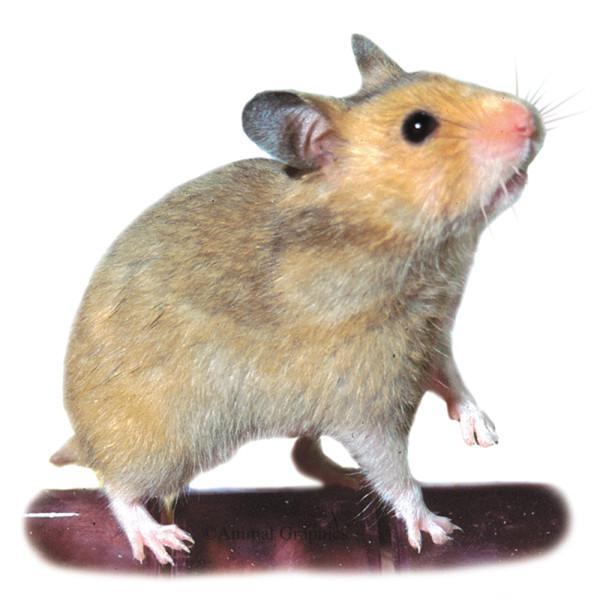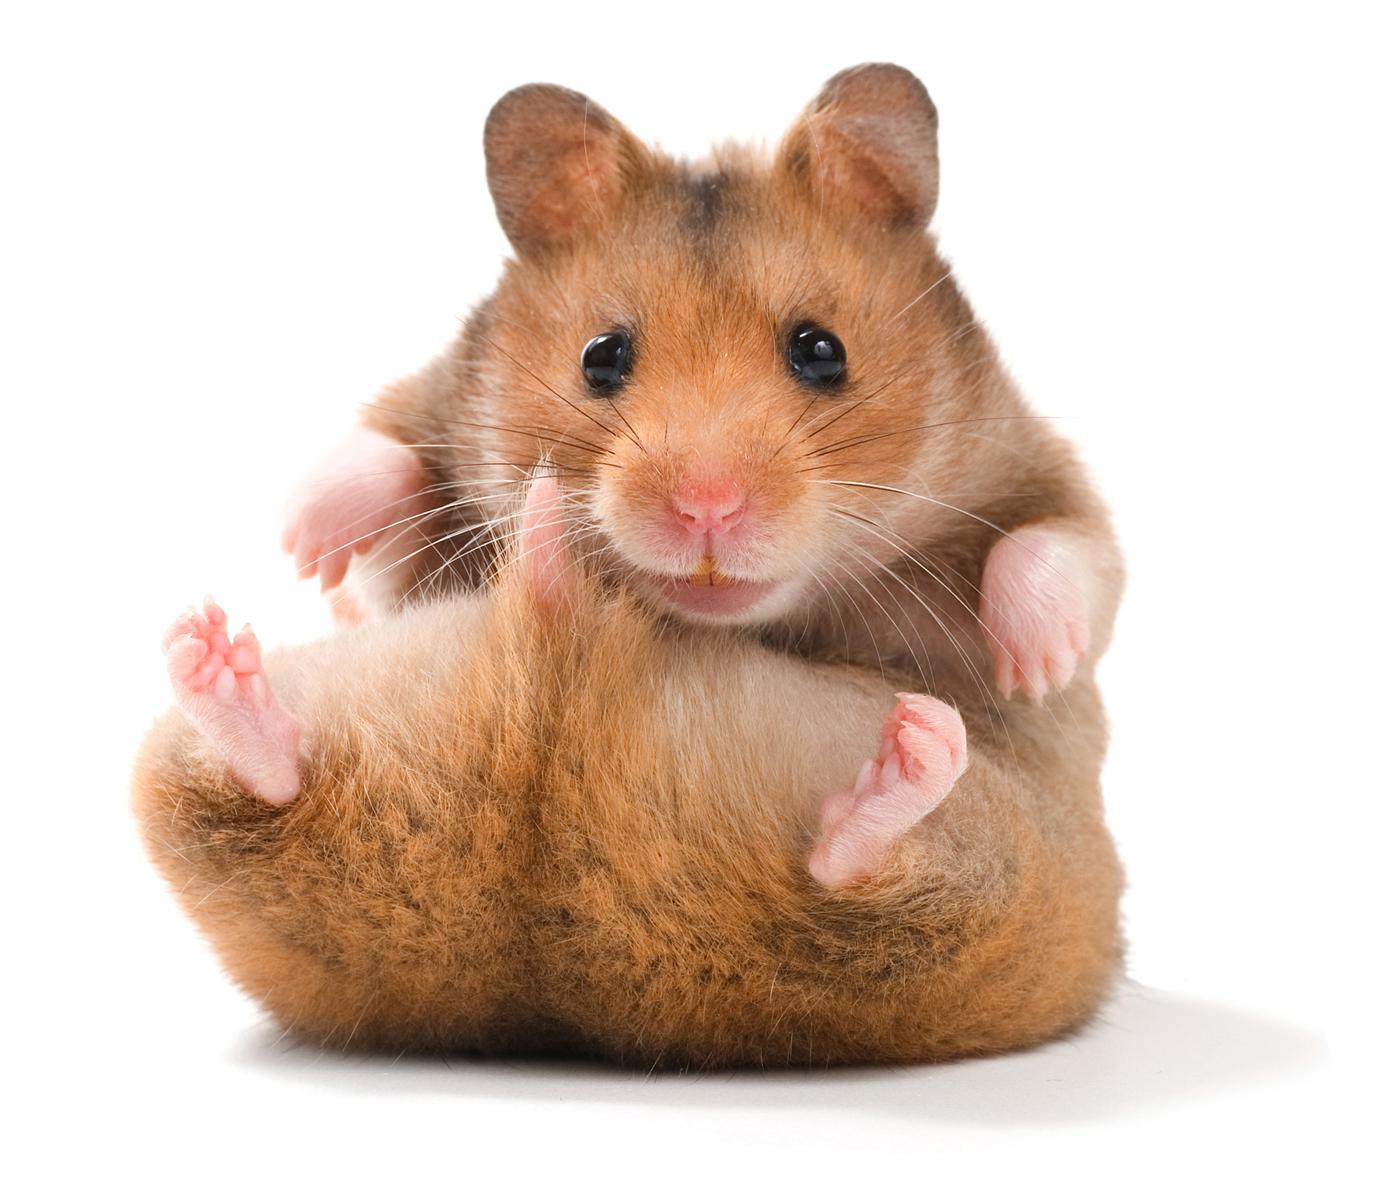The first image is the image on the left, the second image is the image on the right. Assess this claim about the two images: "There are in total three hamsters in the images.". Correct or not? Answer yes or no. No. The first image is the image on the left, the second image is the image on the right. For the images displayed, is the sentence "There is one pair of brown and white hamsters fighting with each other in the image on the left." factually correct? Answer yes or no. No. 